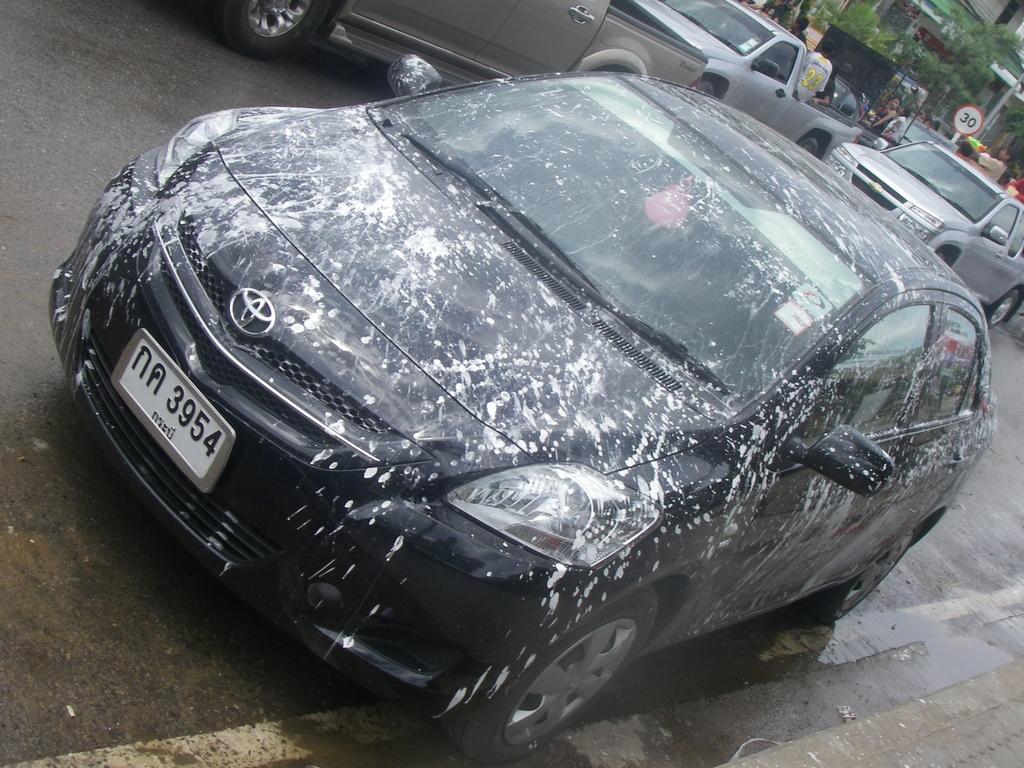Describe this image in one or two sentences. In this picture I can see a car and few mini trucks and I can see a building, trees and few people standing and I can see a sign board and paint on the car. 